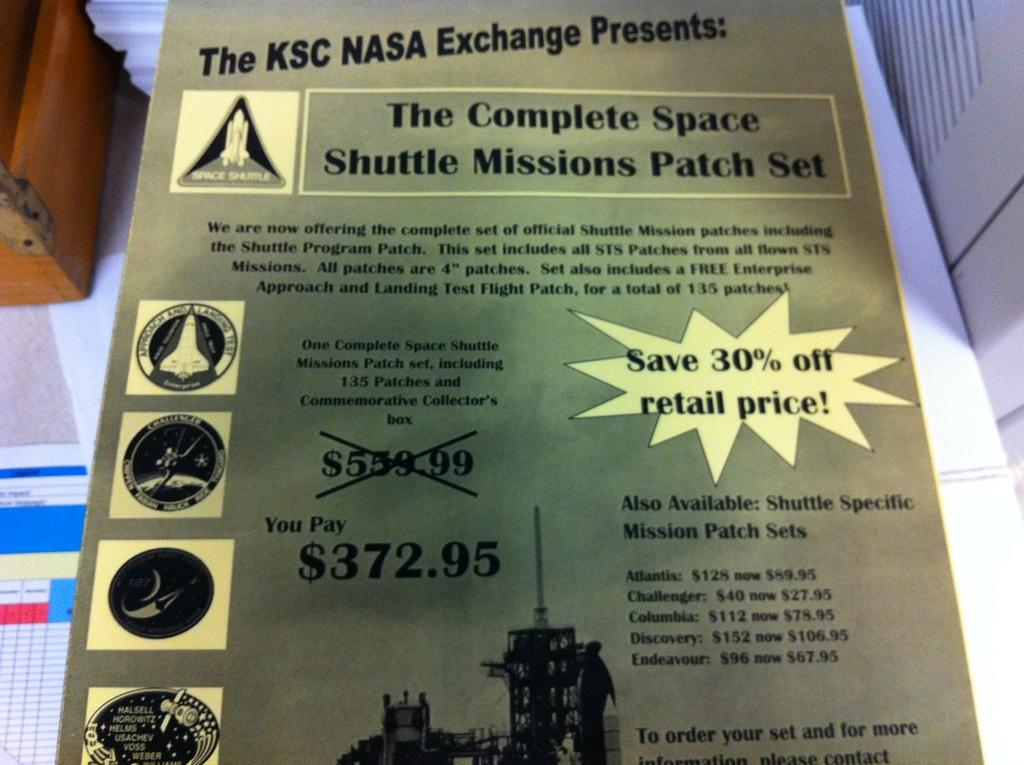Provide a one-sentence caption for the provided image. a flyer about NASA EXCHANGE is laying on a table. 